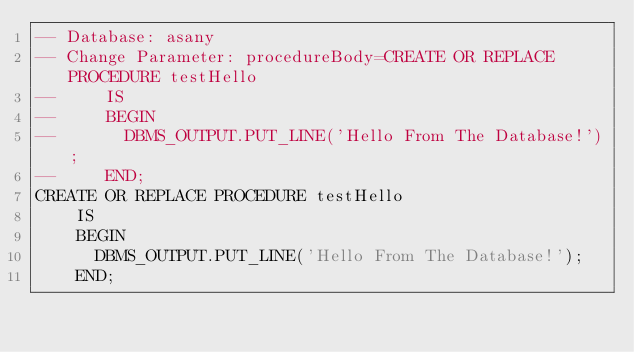<code> <loc_0><loc_0><loc_500><loc_500><_SQL_>-- Database: asany
-- Change Parameter: procedureBody=CREATE OR REPLACE PROCEDURE testHello
--     IS
--     BEGIN
--       DBMS_OUTPUT.PUT_LINE('Hello From The Database!');
--     END;
CREATE OR REPLACE PROCEDURE testHello
    IS
    BEGIN
      DBMS_OUTPUT.PUT_LINE('Hello From The Database!');
    END;
</code> 